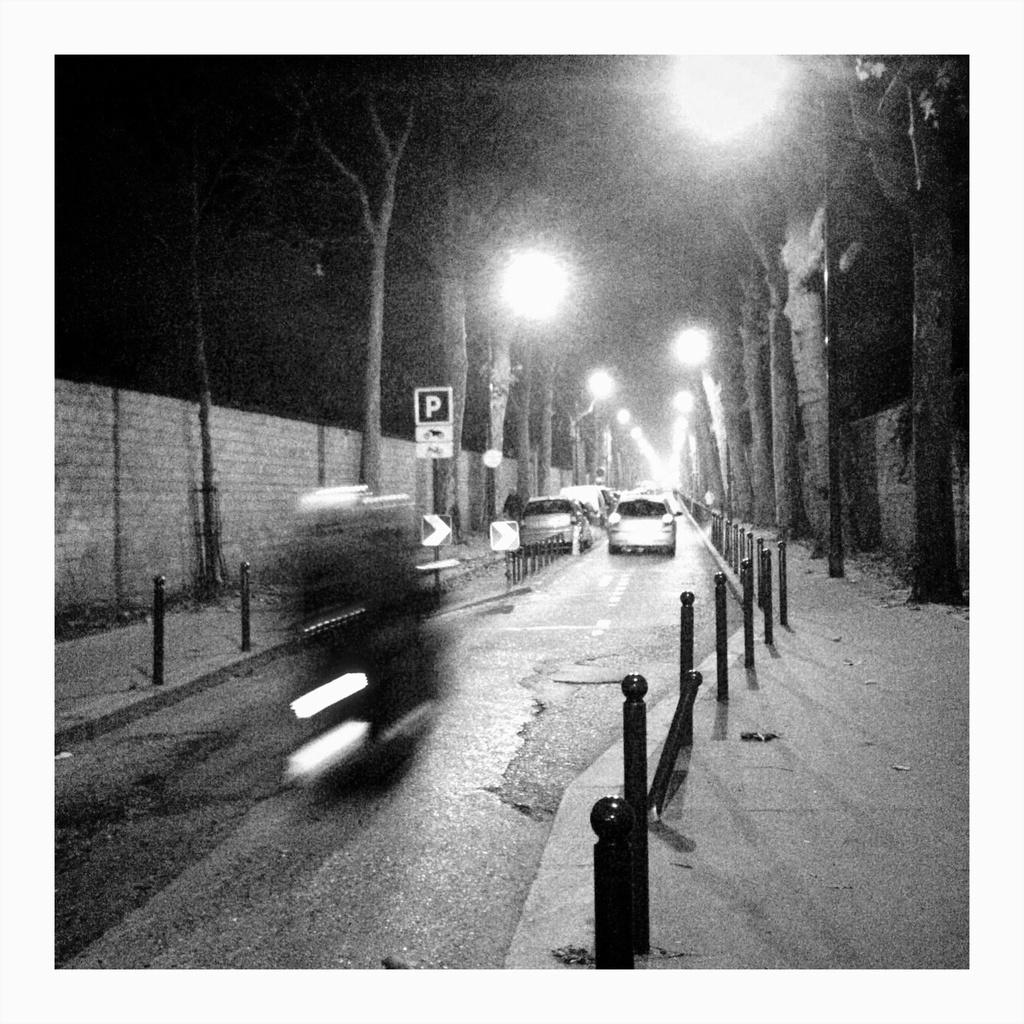What can be seen on the road in the image? There are vehicles on the road in the image. What objects are present in the image besides the vehicles? There are poles, lights, a board, trees, and a wall in the image. What is the color of the background in the image? The background of the image is dark. What type of calendar is hanging on the wall in the image? There is no calendar present in the image; only a wall is visible. What kind of wine is being served at the event in the image? There is no event or wine present in the image. 